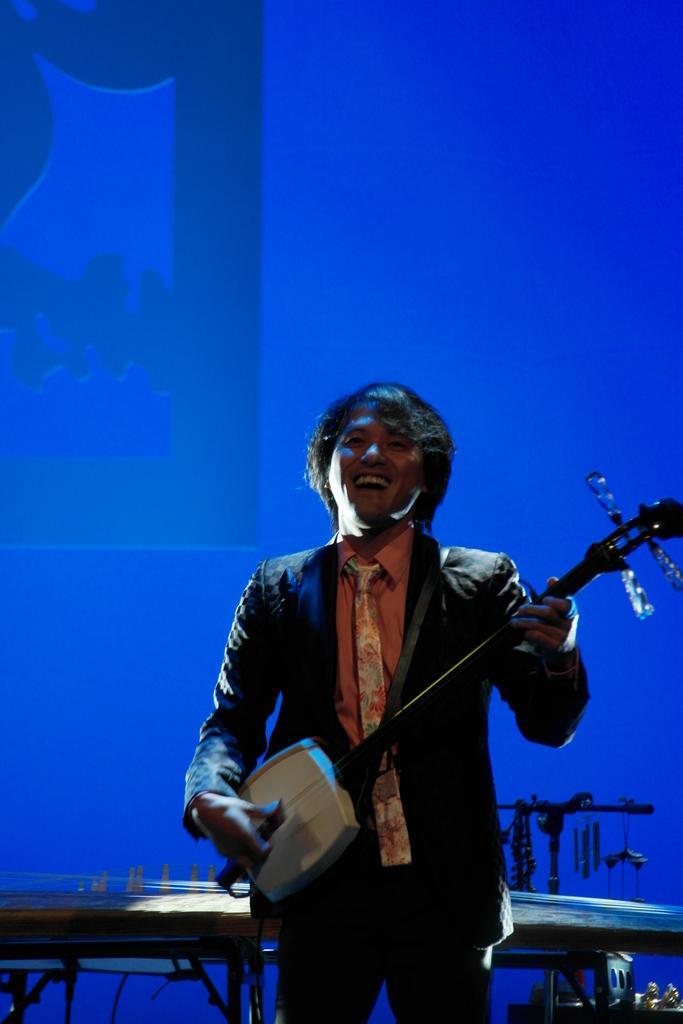In one or two sentences, can you explain what this image depicts? In this picture there is a man standing and smiling holding a musical instrument in his hand. In the background there is a screen which is blue in colour and in front of the screen there is a table. 